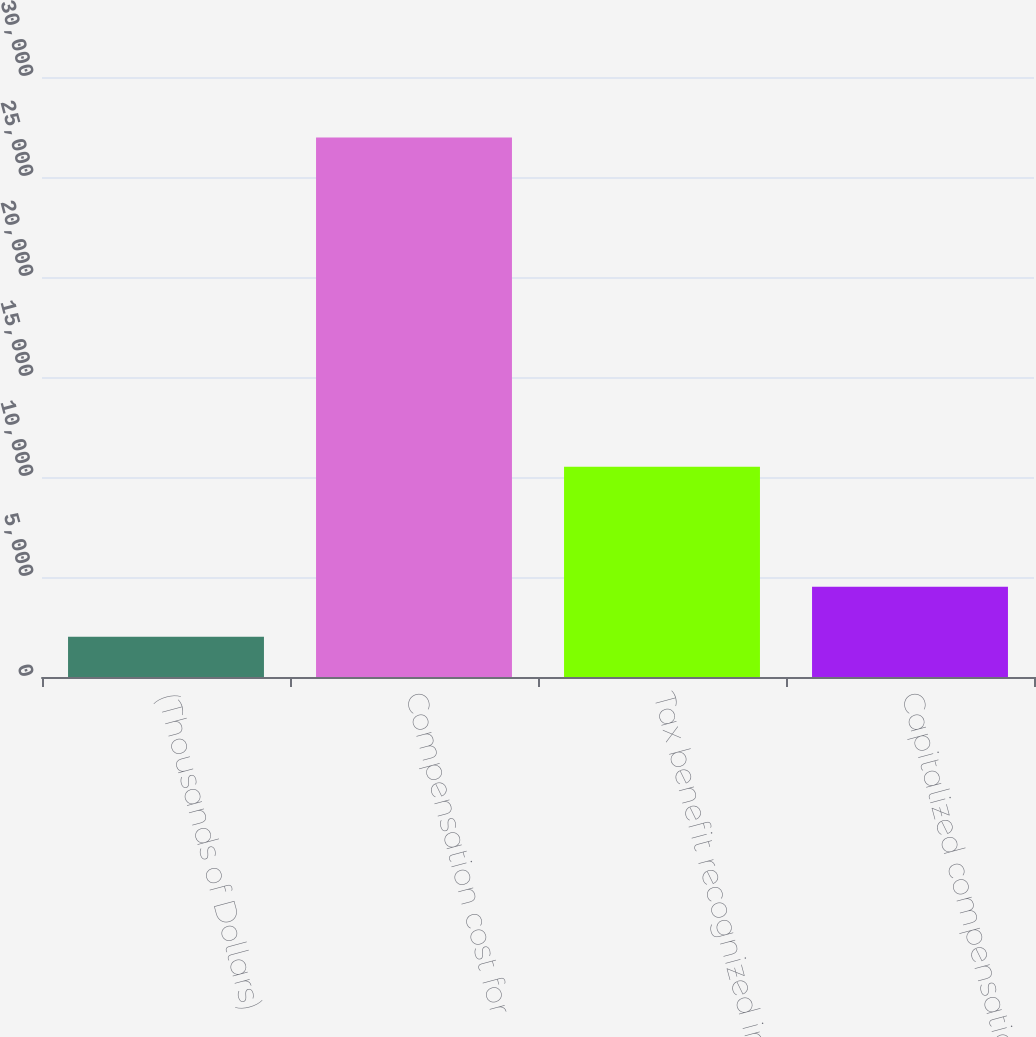<chart> <loc_0><loc_0><loc_500><loc_500><bar_chart><fcel>(Thousands of Dollars)<fcel>Compensation cost for<fcel>Tax benefit recognized in<fcel>Capitalized compensation cost<nl><fcel>2012<fcel>26970<fcel>10513<fcel>4507.8<nl></chart> 